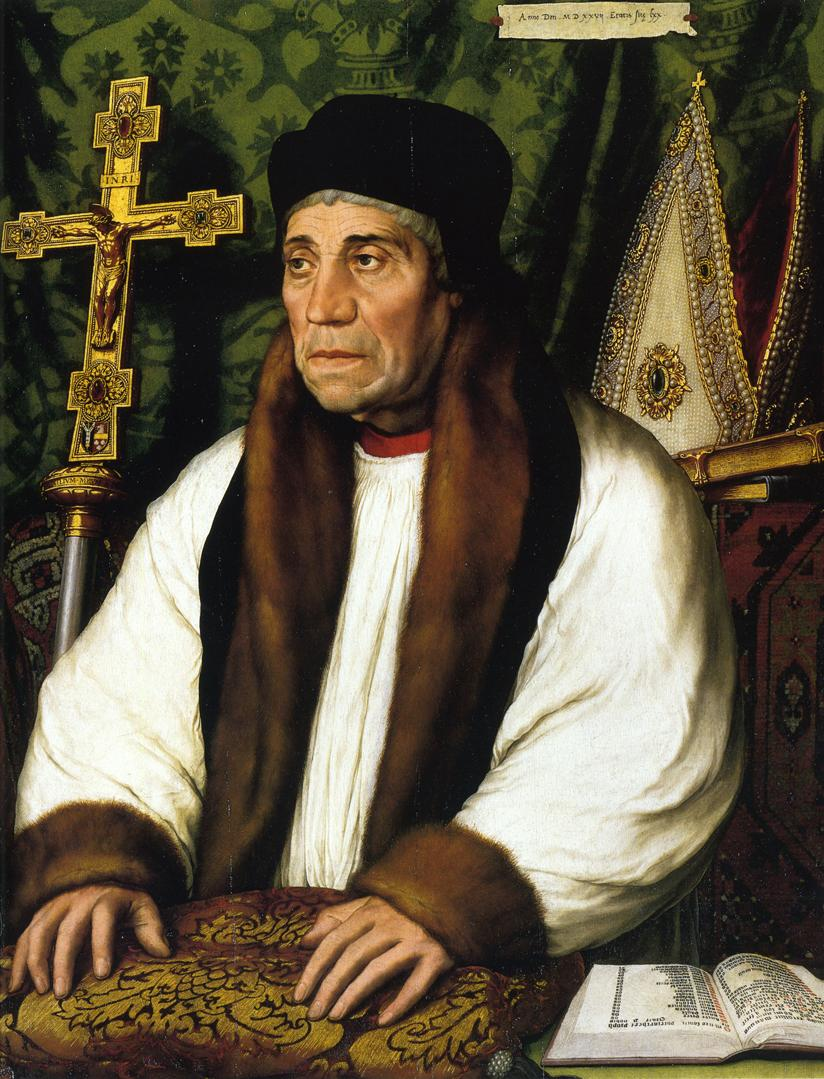If you were to write a fictional story based on this image, what would be the main plot? In a time of religious upheaval and intellectual renaissance, the elderly scholar in the portrait is locked in a race against time to decipher an ancient manuscript that holds the key to a long-lost secret capable of altering the fate of his kingdom. As he delves deeper into the cryptic text, he must navigate palace intrigues, safeguard his discoveries from malevolent forces, and reconcile his spiritual beliefs with the revolutionary knowledge he uncovers. The ornate cross and holy manuscripts in his study become symbols of his dual struggle between faith and knowledge, ultimately leading to a revelation that could bridge the gap between the old world and the new. Could you describe a typical day in the life of the man in the portrait? A typical day for the man in the portrait would likely begin with early morning prayers, followed by a period of quiet reflection and reading the holy texts. He might then conduct or attend scholarly discussions with other learned men, sharing insights and debating theological points. After a modest midday meal, he would spend several hours writing, transcribing texts, or advising those who seek his wisdom. As evening falls, he might lead evening prayers before retiring to study by candlelight, meticulously analyzing ancient manuscripts and noting his observations. His day would end with personal prayers and a sense of fulfillment from his unwavering dedication to faith and knowledge. 